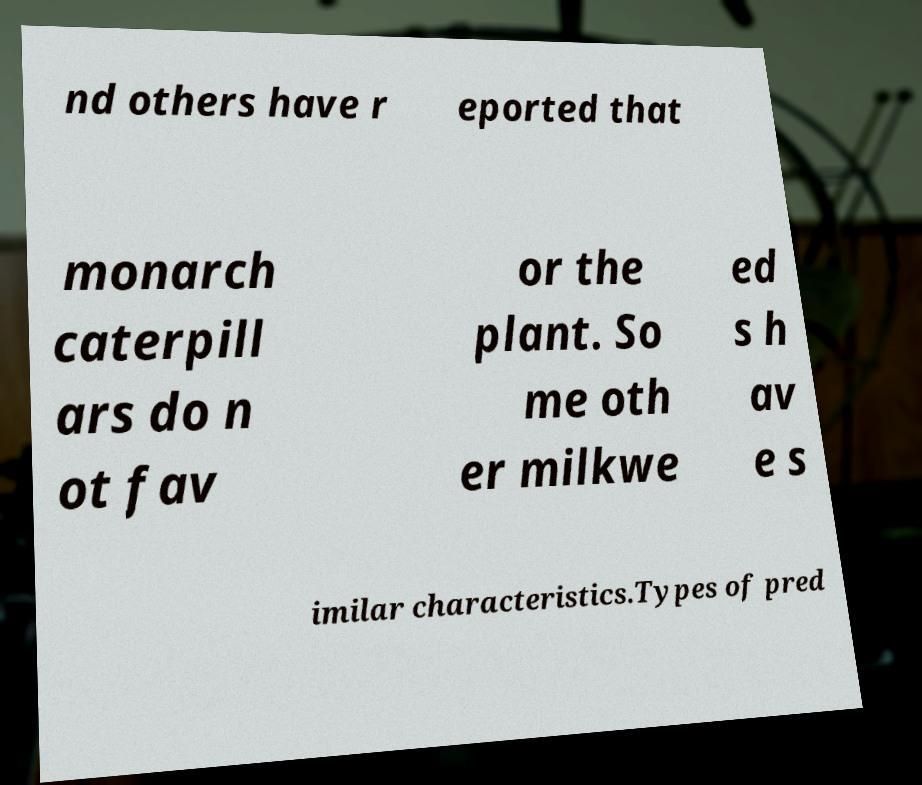What messages or text are displayed in this image? I need them in a readable, typed format. nd others have r eported that monarch caterpill ars do n ot fav or the plant. So me oth er milkwe ed s h av e s imilar characteristics.Types of pred 